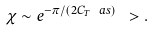<formula> <loc_0><loc_0><loc_500><loc_500>\chi \sim e ^ { - { \pi } / ( 2 C _ { T } \ a s ) } \ > .</formula> 